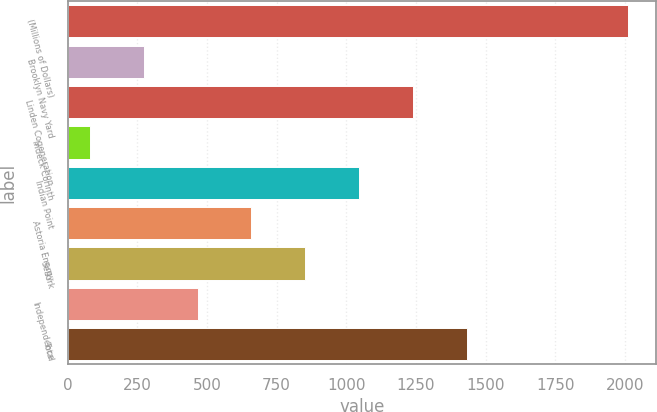Convert chart to OTSL. <chart><loc_0><loc_0><loc_500><loc_500><bar_chart><fcel>(Millions of Dollars)<fcel>Brooklyn Navy Yard<fcel>Linden Cogeneration<fcel>Indeck Corinth<fcel>Indian Point<fcel>Astoria Energy<fcel>Selkirk<fcel>Independence<fcel>Total<nl><fcel>2013<fcel>272.4<fcel>1239.4<fcel>79<fcel>1046<fcel>659.2<fcel>852.6<fcel>465.8<fcel>1432.8<nl></chart> 